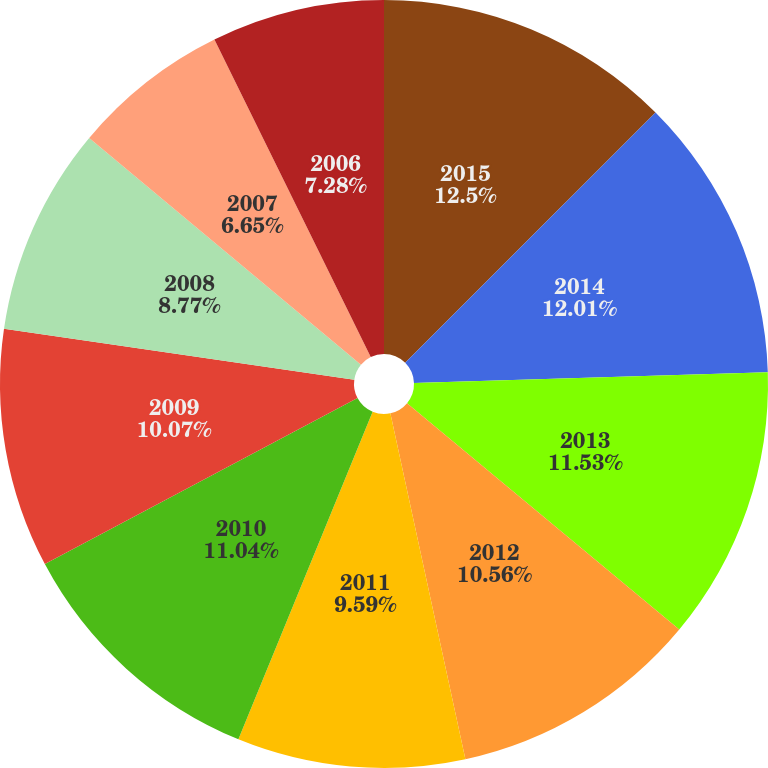<chart> <loc_0><loc_0><loc_500><loc_500><pie_chart><fcel>2015<fcel>2014<fcel>2013<fcel>2012<fcel>2011<fcel>2010<fcel>2009<fcel>2008<fcel>2007<fcel>2006<nl><fcel>12.5%<fcel>12.01%<fcel>11.53%<fcel>10.56%<fcel>9.59%<fcel>11.04%<fcel>10.07%<fcel>8.77%<fcel>6.65%<fcel>7.28%<nl></chart> 